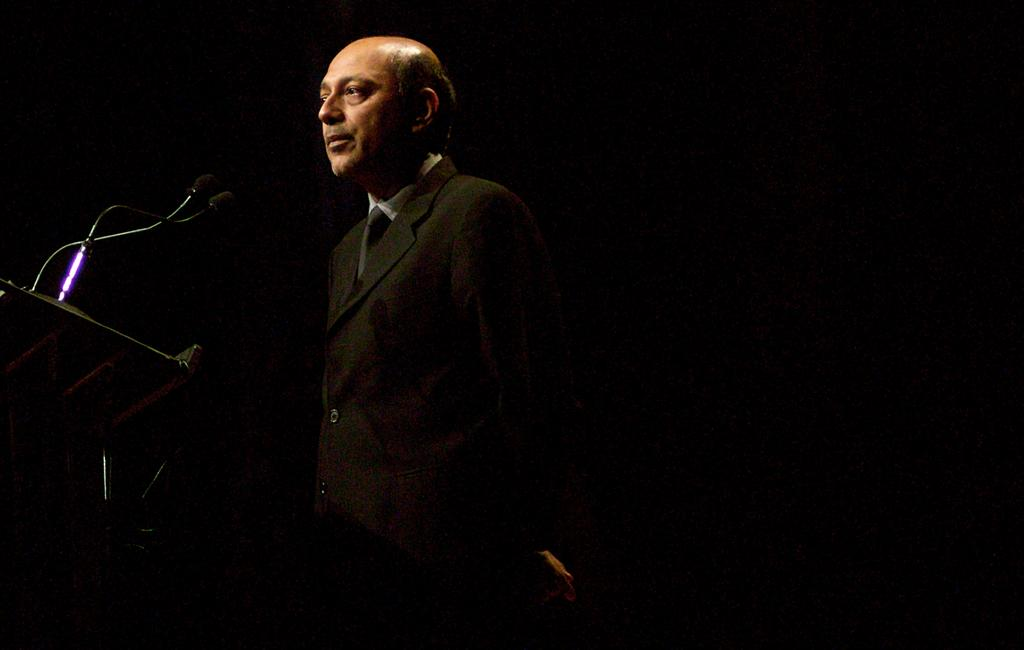What is the person in the image wearing? The person is wearing a suit. What objects are present in the image that are related to sound? There are microphones and microphone stands in the image. What is the color of the background in the image? The background of the image is black. What type of eggnog is being served at the event in the image? There is no mention of eggnog or any event in the image; it only features a person wearing a suit, microphones, microphone stands, and a black background. 